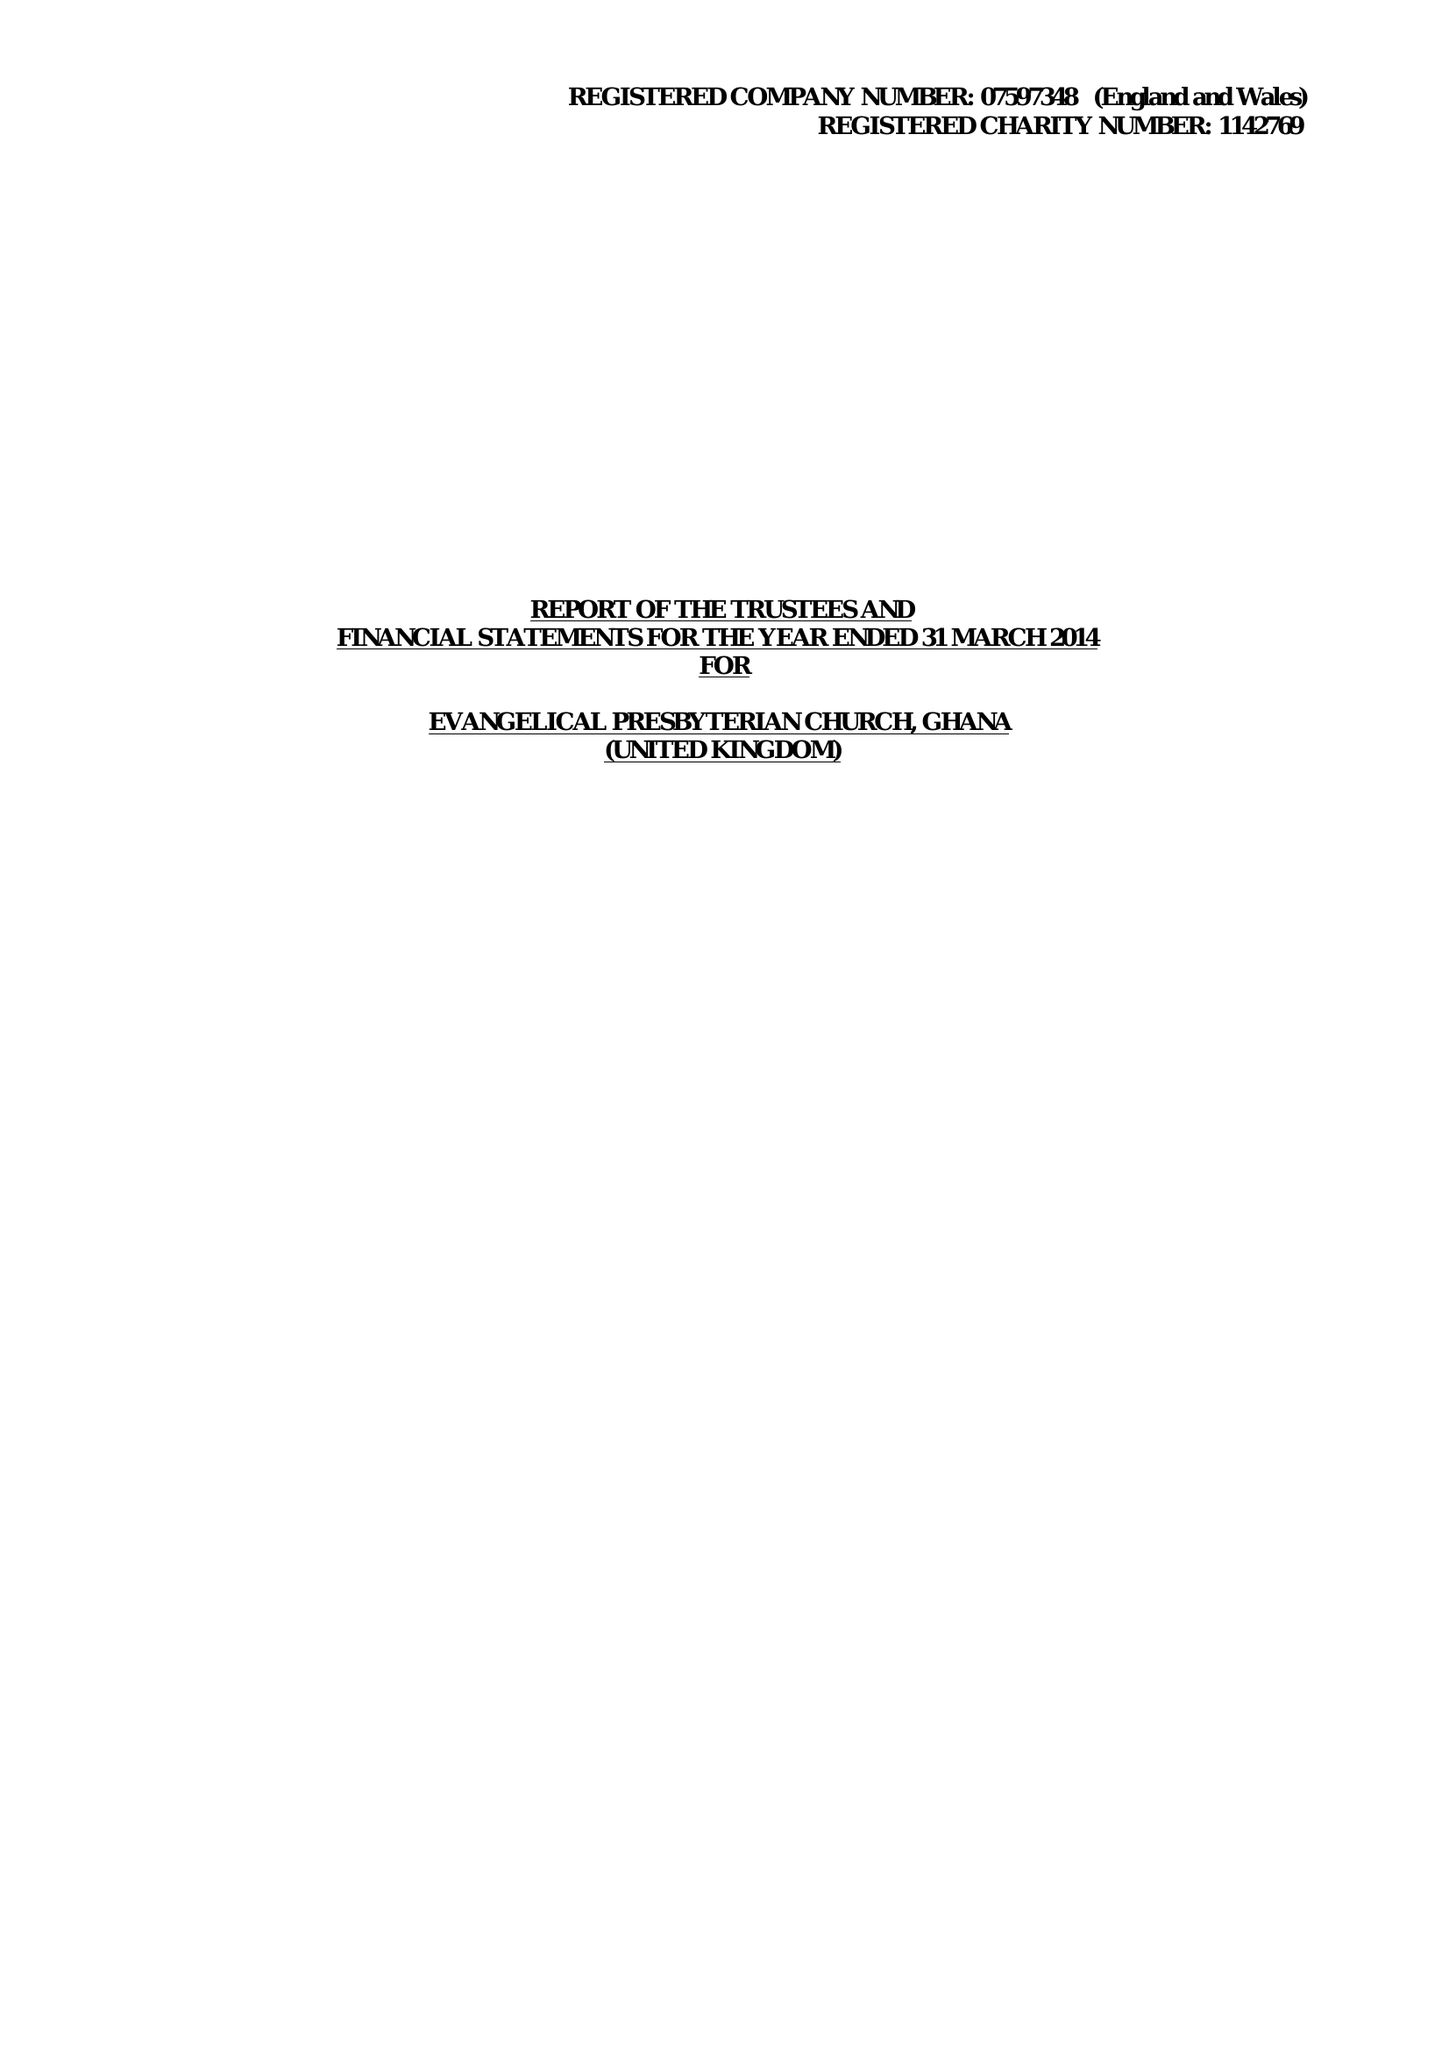What is the value for the report_date?
Answer the question using a single word or phrase. 2014-03-31 